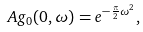Convert formula to latex. <formula><loc_0><loc_0><loc_500><loc_500>A g _ { 0 } ( 0 , \omega ) = e ^ { - \frac { \pi } { 2 } \omega ^ { 2 } } ,</formula> 